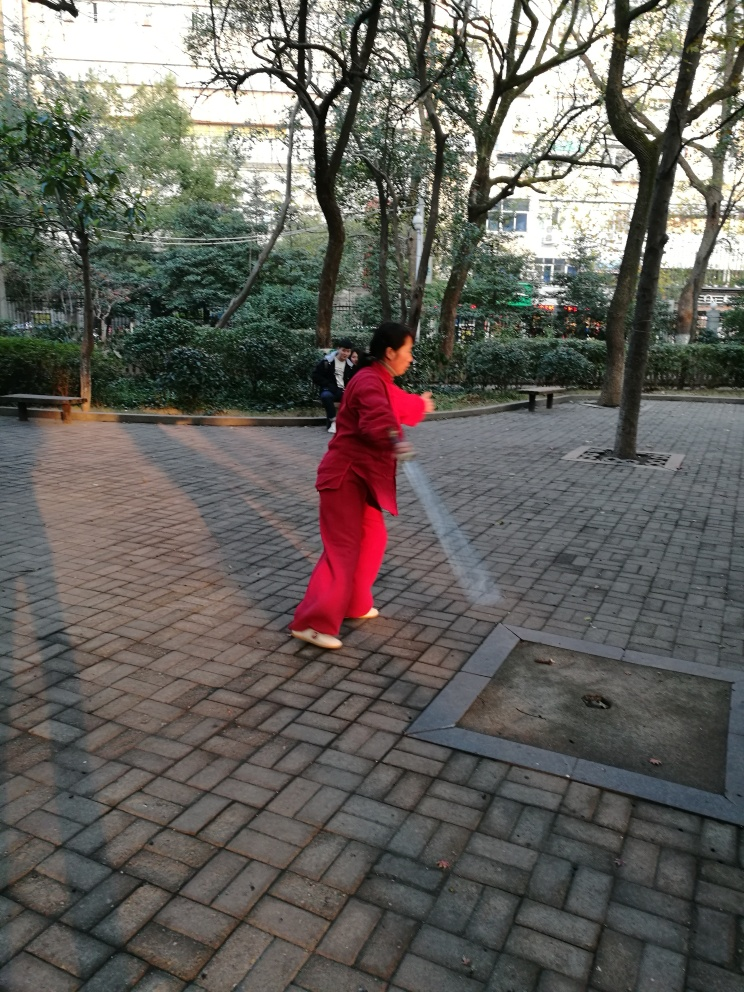Can you describe the surroundings and how they contribute to the atmosphere of the image? The surroundings, with mature trees and a well-maintained paving, suggest a tranquil urban park. The vegetation provides a serene backdrop and suggests a peaceful retreat amidst a likely busy city environment. The choice of undertaking a solo activity here underscores the park's role as a sanctuary for personal relaxation and reflection. What time of day does it appear to be, and how does that influence the activities in the park? Based on the lighting and shadows, it seems to be morning or late afternoon, which are popular times for individuals to visit parks for exercise or leisure due to the cooler and more comfortable temperatures. This specific time of day encourages more active and engaged participation in outdoor activities. 